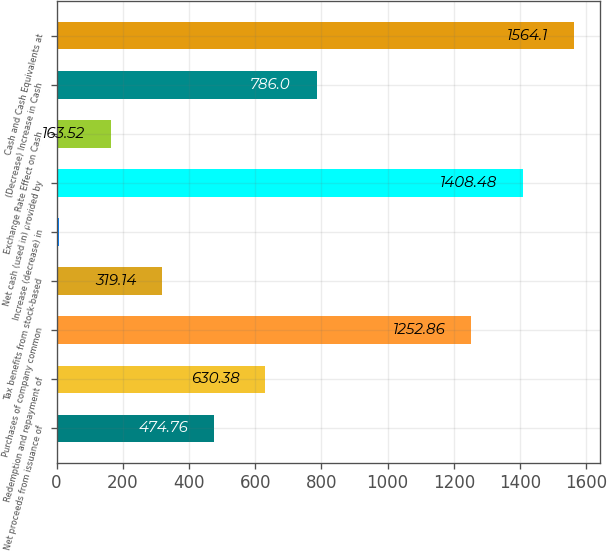Convert chart to OTSL. <chart><loc_0><loc_0><loc_500><loc_500><bar_chart><fcel>Net proceeds from issuance of<fcel>Redemption and repayment of<fcel>Purchases of company common<fcel>Tax benefits from stock-based<fcel>Increase (decrease) in<fcel>Net cash (used in) provided by<fcel>Exchange Rate Effect on Cash<fcel>(Decrease) Increase in Cash<fcel>Cash and Cash Equivalents at<nl><fcel>474.76<fcel>630.38<fcel>1252.86<fcel>319.14<fcel>7.9<fcel>1408.48<fcel>163.52<fcel>786<fcel>1564.1<nl></chart> 